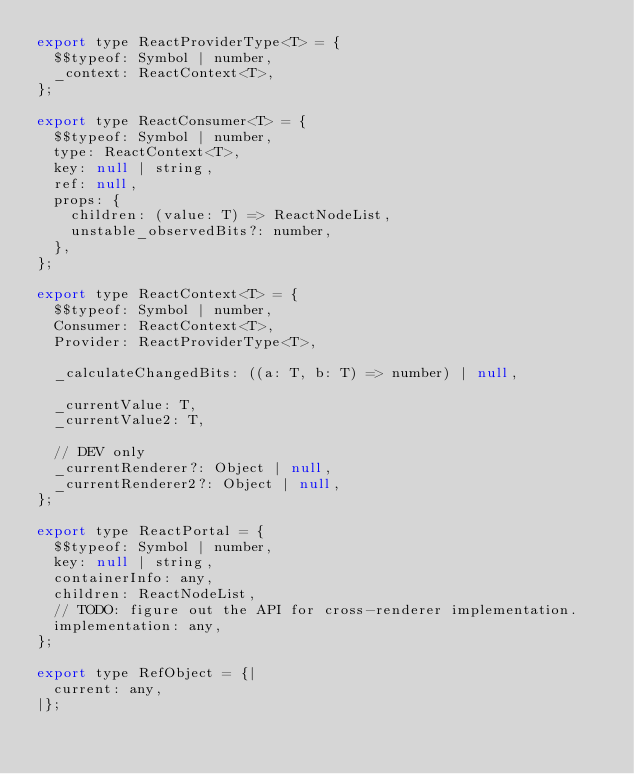<code> <loc_0><loc_0><loc_500><loc_500><_JavaScript_>export type ReactProviderType<T> = {
  $$typeof: Symbol | number,
  _context: ReactContext<T>,
};

export type ReactConsumer<T> = {
  $$typeof: Symbol | number,
  type: ReactContext<T>,
  key: null | string,
  ref: null,
  props: {
    children: (value: T) => ReactNodeList,
    unstable_observedBits?: number,
  },
};

export type ReactContext<T> = {
  $$typeof: Symbol | number,
  Consumer: ReactContext<T>,
  Provider: ReactProviderType<T>,

  _calculateChangedBits: ((a: T, b: T) => number) | null,

  _currentValue: T,
  _currentValue2: T,

  // DEV only
  _currentRenderer?: Object | null,
  _currentRenderer2?: Object | null,
};

export type ReactPortal = {
  $$typeof: Symbol | number,
  key: null | string,
  containerInfo: any,
  children: ReactNodeList,
  // TODO: figure out the API for cross-renderer implementation.
  implementation: any,
};

export type RefObject = {|
  current: any,
|};
</code> 